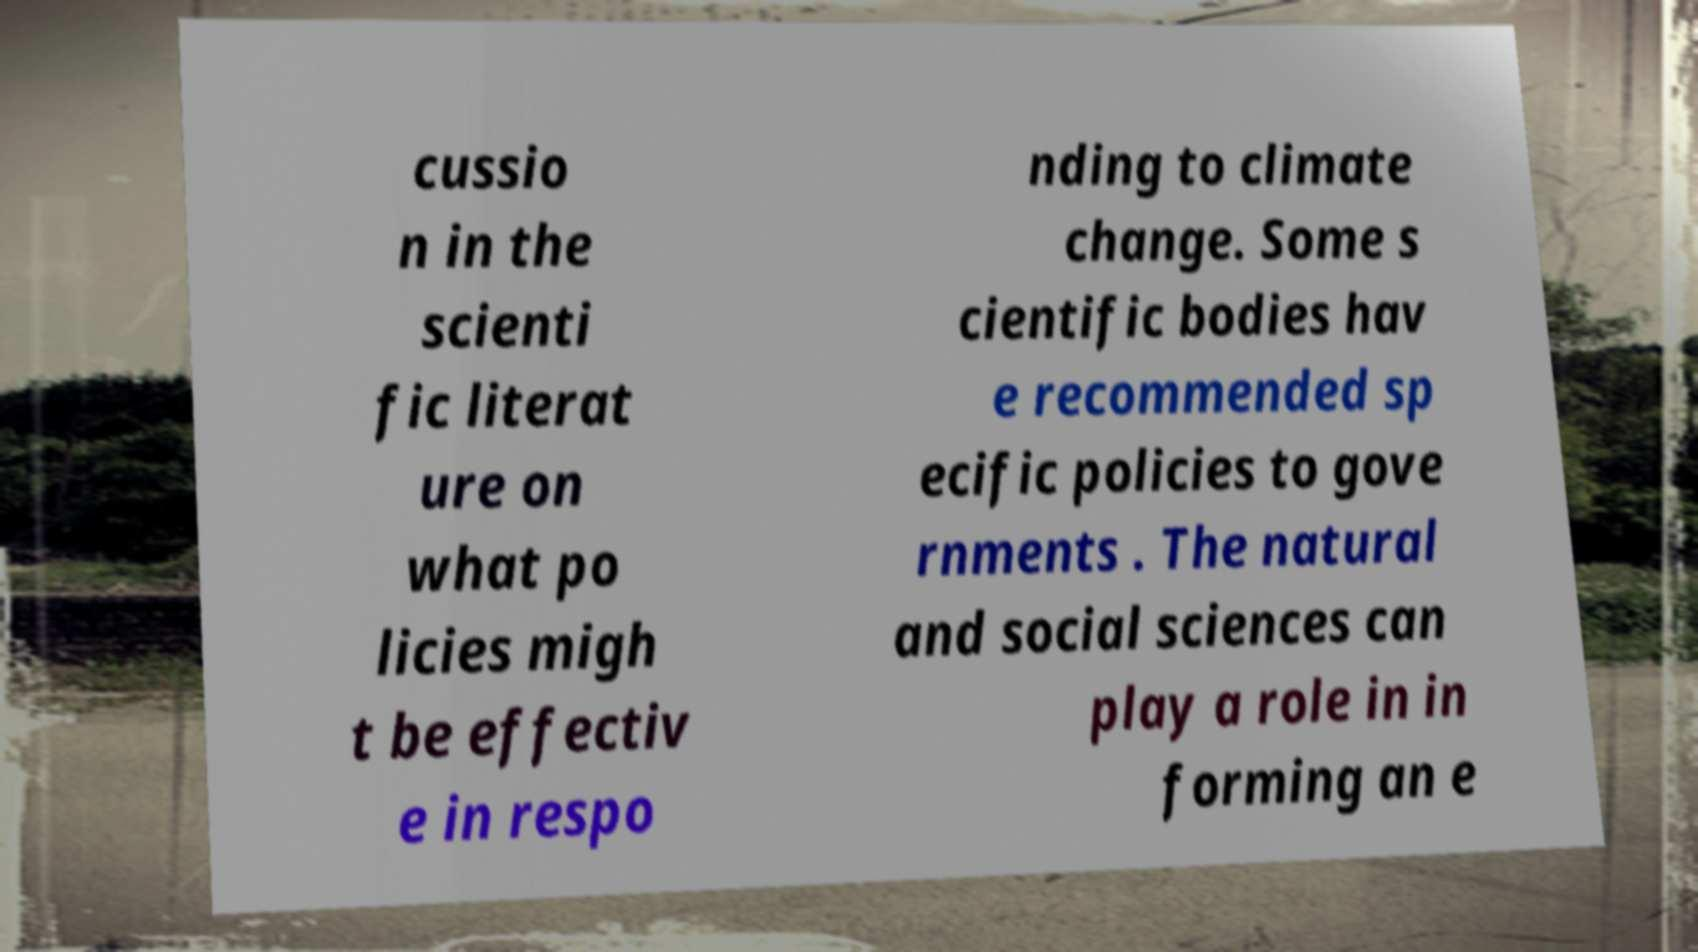Can you accurately transcribe the text from the provided image for me? cussio n in the scienti fic literat ure on what po licies migh t be effectiv e in respo nding to climate change. Some s cientific bodies hav e recommended sp ecific policies to gove rnments . The natural and social sciences can play a role in in forming an e 